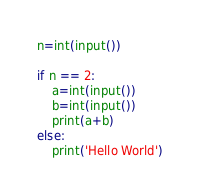Convert code to text. <code><loc_0><loc_0><loc_500><loc_500><_Python_>n=int(input())

if n == 2:
    a=int(input())
    b=int(input())
    print(a+b)
else:
    print('Hello World')</code> 